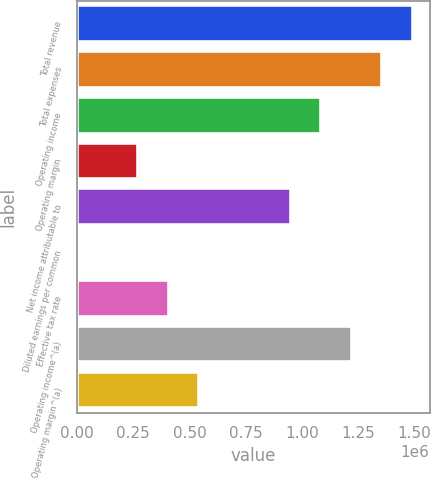Convert chart. <chart><loc_0><loc_0><loc_500><loc_500><bar_chart><fcel>Total revenue<fcel>Total expenses<fcel>Operating income<fcel>Operating margin<fcel>Net income attributable to<fcel>Diluted earnings per common<fcel>Effective tax rate<fcel>Operating income^(a)<fcel>Operating margin^(a)<nl><fcel>1.49231e+06<fcel>1.35664e+06<fcel>1.08532e+06<fcel>271335<fcel>949653<fcel>7.37<fcel>406998<fcel>1.22098e+06<fcel>542662<nl></chart> 